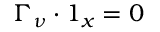Convert formula to latex. <formula><loc_0><loc_0><loc_500><loc_500>\Gamma _ { \nu } \cdot 1 _ { x } = 0</formula> 